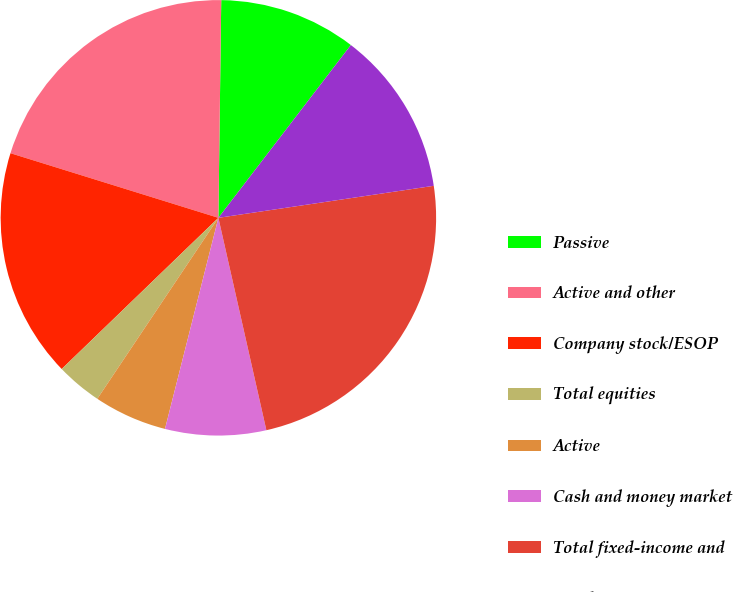Convert chart. <chart><loc_0><loc_0><loc_500><loc_500><pie_chart><fcel>Passive<fcel>Active and other<fcel>Company stock/ESOP<fcel>Total equities<fcel>Active<fcel>Cash and money market<fcel>Total fixed-income and<fcel>Total<nl><fcel>10.2%<fcel>20.41%<fcel>17.01%<fcel>3.4%<fcel>5.44%<fcel>7.48%<fcel>23.81%<fcel>12.24%<nl></chart> 